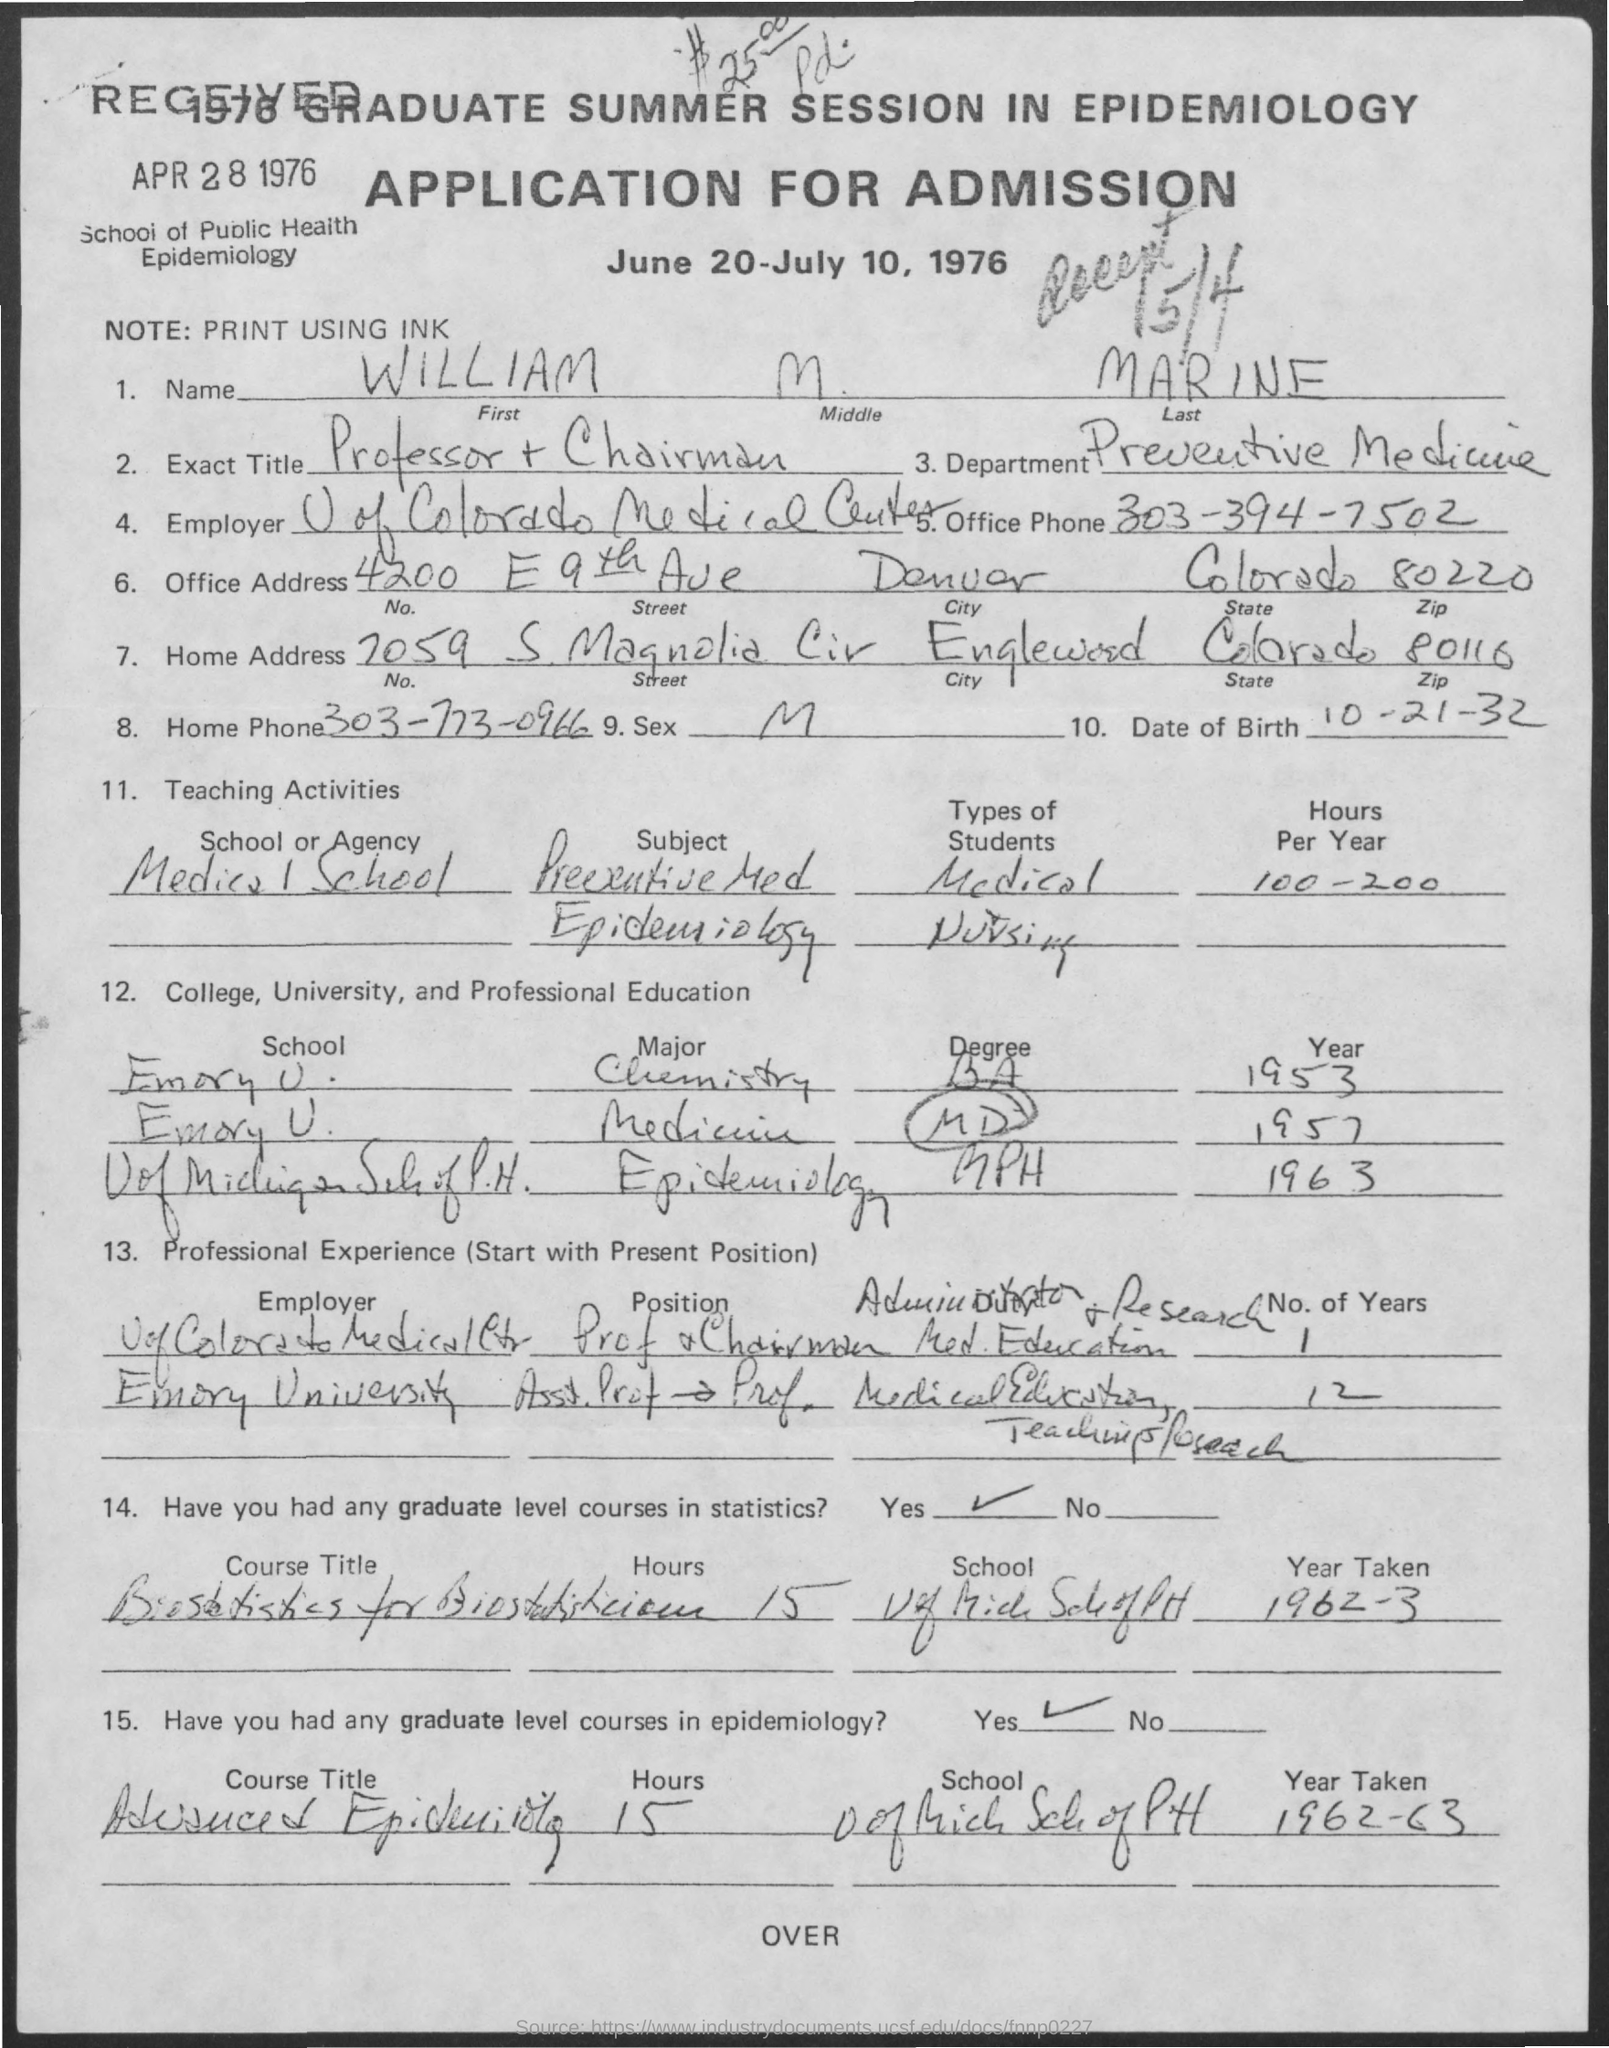What is written in the Note Field ?
Ensure brevity in your answer.  Print Using Ink. What is the Office Phone Number ?
Give a very brief answer. 303-394-7502. What is the Home Phone Number ?
Ensure brevity in your answer.  303-773-0966. What is the Home Address Number ?
Provide a short and direct response. 7059. 